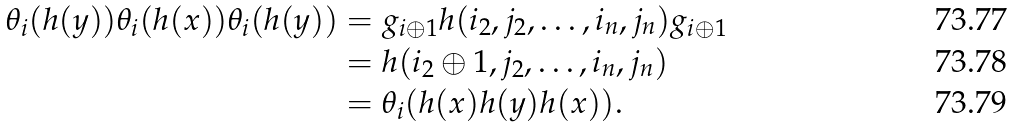Convert formula to latex. <formula><loc_0><loc_0><loc_500><loc_500>\theta _ { i } ( h ( y ) ) \theta _ { i } ( h ( x ) ) \theta _ { i } ( h ( y ) ) & = g _ { i \oplus 1 } h ( i _ { 2 } , j _ { 2 } , \dots , i _ { n } , j _ { n } ) g _ { i \oplus 1 } \\ & = h ( i _ { 2 } \oplus 1 , j _ { 2 } , \dots , i _ { n } , j _ { n } ) \\ & = \theta _ { i } ( h ( x ) h ( y ) h ( x ) ) .</formula> 